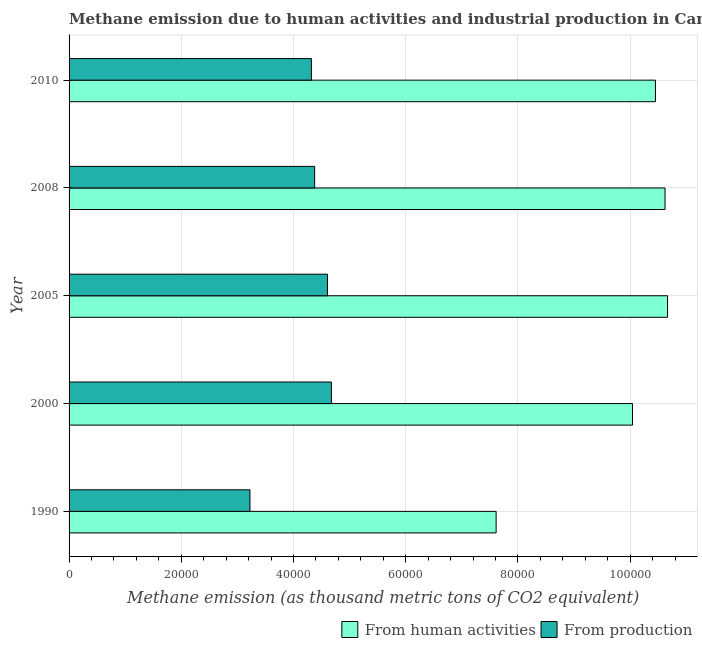How many different coloured bars are there?
Ensure brevity in your answer.  2. How many bars are there on the 4th tick from the top?
Your answer should be compact. 2. What is the label of the 3rd group of bars from the top?
Make the answer very short. 2005. What is the amount of emissions generated from industries in 1990?
Your answer should be compact. 3.22e+04. Across all years, what is the maximum amount of emissions from human activities?
Your answer should be compact. 1.07e+05. Across all years, what is the minimum amount of emissions generated from industries?
Keep it short and to the point. 3.22e+04. In which year was the amount of emissions generated from industries minimum?
Your answer should be compact. 1990. What is the total amount of emissions generated from industries in the graph?
Offer a terse response. 2.12e+05. What is the difference between the amount of emissions generated from industries in 2008 and that in 2010?
Your response must be concise. 582.1. What is the difference between the amount of emissions from human activities in 2000 and the amount of emissions generated from industries in 2005?
Give a very brief answer. 5.44e+04. What is the average amount of emissions from human activities per year?
Your answer should be very brief. 9.88e+04. In the year 2010, what is the difference between the amount of emissions from human activities and amount of emissions generated from industries?
Offer a very short reply. 6.13e+04. In how many years, is the amount of emissions generated from industries greater than 52000 thousand metric tons?
Provide a succinct answer. 0. What is the ratio of the amount of emissions generated from industries in 2005 to that in 2010?
Provide a short and direct response. 1.07. What is the difference between the highest and the second highest amount of emissions generated from industries?
Your response must be concise. 705.9. What is the difference between the highest and the lowest amount of emissions from human activities?
Your response must be concise. 3.06e+04. Is the sum of the amount of emissions generated from industries in 1990 and 2010 greater than the maximum amount of emissions from human activities across all years?
Provide a short and direct response. No. What does the 1st bar from the top in 2010 represents?
Give a very brief answer. From production. What does the 2nd bar from the bottom in 2000 represents?
Keep it short and to the point. From production. How many years are there in the graph?
Ensure brevity in your answer.  5. What is the difference between two consecutive major ticks on the X-axis?
Offer a terse response. 2.00e+04. Are the values on the major ticks of X-axis written in scientific E-notation?
Ensure brevity in your answer.  No. Does the graph contain any zero values?
Your answer should be very brief. No. How are the legend labels stacked?
Provide a short and direct response. Horizontal. What is the title of the graph?
Offer a terse response. Methane emission due to human activities and industrial production in Canada. Does "Non-resident workers" appear as one of the legend labels in the graph?
Provide a succinct answer. No. What is the label or title of the X-axis?
Your answer should be compact. Methane emission (as thousand metric tons of CO2 equivalent). What is the Methane emission (as thousand metric tons of CO2 equivalent) in From human activities in 1990?
Make the answer very short. 7.61e+04. What is the Methane emission (as thousand metric tons of CO2 equivalent) in From production in 1990?
Offer a terse response. 3.22e+04. What is the Methane emission (as thousand metric tons of CO2 equivalent) of From human activities in 2000?
Your answer should be compact. 1.00e+05. What is the Methane emission (as thousand metric tons of CO2 equivalent) in From production in 2000?
Your answer should be compact. 4.68e+04. What is the Methane emission (as thousand metric tons of CO2 equivalent) of From human activities in 2005?
Offer a terse response. 1.07e+05. What is the Methane emission (as thousand metric tons of CO2 equivalent) of From production in 2005?
Your response must be concise. 4.60e+04. What is the Methane emission (as thousand metric tons of CO2 equivalent) of From human activities in 2008?
Give a very brief answer. 1.06e+05. What is the Methane emission (as thousand metric tons of CO2 equivalent) of From production in 2008?
Your response must be concise. 4.38e+04. What is the Methane emission (as thousand metric tons of CO2 equivalent) of From human activities in 2010?
Your answer should be very brief. 1.04e+05. What is the Methane emission (as thousand metric tons of CO2 equivalent) of From production in 2010?
Offer a terse response. 4.32e+04. Across all years, what is the maximum Methane emission (as thousand metric tons of CO2 equivalent) of From human activities?
Your answer should be very brief. 1.07e+05. Across all years, what is the maximum Methane emission (as thousand metric tons of CO2 equivalent) in From production?
Provide a short and direct response. 4.68e+04. Across all years, what is the minimum Methane emission (as thousand metric tons of CO2 equivalent) of From human activities?
Provide a succinct answer. 7.61e+04. Across all years, what is the minimum Methane emission (as thousand metric tons of CO2 equivalent) in From production?
Keep it short and to the point. 3.22e+04. What is the total Methane emission (as thousand metric tons of CO2 equivalent) in From human activities in the graph?
Your response must be concise. 4.94e+05. What is the total Methane emission (as thousand metric tons of CO2 equivalent) of From production in the graph?
Ensure brevity in your answer.  2.12e+05. What is the difference between the Methane emission (as thousand metric tons of CO2 equivalent) of From human activities in 1990 and that in 2000?
Provide a short and direct response. -2.43e+04. What is the difference between the Methane emission (as thousand metric tons of CO2 equivalent) in From production in 1990 and that in 2000?
Keep it short and to the point. -1.45e+04. What is the difference between the Methane emission (as thousand metric tons of CO2 equivalent) of From human activities in 1990 and that in 2005?
Make the answer very short. -3.06e+04. What is the difference between the Methane emission (as thousand metric tons of CO2 equivalent) in From production in 1990 and that in 2005?
Your answer should be very brief. -1.38e+04. What is the difference between the Methane emission (as thousand metric tons of CO2 equivalent) in From human activities in 1990 and that in 2008?
Provide a short and direct response. -3.01e+04. What is the difference between the Methane emission (as thousand metric tons of CO2 equivalent) in From production in 1990 and that in 2008?
Offer a very short reply. -1.15e+04. What is the difference between the Methane emission (as thousand metric tons of CO2 equivalent) in From human activities in 1990 and that in 2010?
Your answer should be compact. -2.84e+04. What is the difference between the Methane emission (as thousand metric tons of CO2 equivalent) in From production in 1990 and that in 2010?
Ensure brevity in your answer.  -1.09e+04. What is the difference between the Methane emission (as thousand metric tons of CO2 equivalent) of From human activities in 2000 and that in 2005?
Provide a short and direct response. -6253.4. What is the difference between the Methane emission (as thousand metric tons of CO2 equivalent) in From production in 2000 and that in 2005?
Provide a short and direct response. 705.9. What is the difference between the Methane emission (as thousand metric tons of CO2 equivalent) in From human activities in 2000 and that in 2008?
Give a very brief answer. -5804.7. What is the difference between the Methane emission (as thousand metric tons of CO2 equivalent) of From production in 2000 and that in 2008?
Provide a short and direct response. 2987.1. What is the difference between the Methane emission (as thousand metric tons of CO2 equivalent) in From human activities in 2000 and that in 2010?
Make the answer very short. -4095.9. What is the difference between the Methane emission (as thousand metric tons of CO2 equivalent) in From production in 2000 and that in 2010?
Your answer should be compact. 3569.2. What is the difference between the Methane emission (as thousand metric tons of CO2 equivalent) of From human activities in 2005 and that in 2008?
Provide a short and direct response. 448.7. What is the difference between the Methane emission (as thousand metric tons of CO2 equivalent) of From production in 2005 and that in 2008?
Keep it short and to the point. 2281.2. What is the difference between the Methane emission (as thousand metric tons of CO2 equivalent) in From human activities in 2005 and that in 2010?
Your response must be concise. 2157.5. What is the difference between the Methane emission (as thousand metric tons of CO2 equivalent) of From production in 2005 and that in 2010?
Your response must be concise. 2863.3. What is the difference between the Methane emission (as thousand metric tons of CO2 equivalent) in From human activities in 2008 and that in 2010?
Offer a very short reply. 1708.8. What is the difference between the Methane emission (as thousand metric tons of CO2 equivalent) in From production in 2008 and that in 2010?
Your response must be concise. 582.1. What is the difference between the Methane emission (as thousand metric tons of CO2 equivalent) in From human activities in 1990 and the Methane emission (as thousand metric tons of CO2 equivalent) in From production in 2000?
Offer a very short reply. 2.94e+04. What is the difference between the Methane emission (as thousand metric tons of CO2 equivalent) of From human activities in 1990 and the Methane emission (as thousand metric tons of CO2 equivalent) of From production in 2005?
Offer a terse response. 3.01e+04. What is the difference between the Methane emission (as thousand metric tons of CO2 equivalent) in From human activities in 1990 and the Methane emission (as thousand metric tons of CO2 equivalent) in From production in 2008?
Offer a very short reply. 3.23e+04. What is the difference between the Methane emission (as thousand metric tons of CO2 equivalent) in From human activities in 1990 and the Methane emission (as thousand metric tons of CO2 equivalent) in From production in 2010?
Provide a succinct answer. 3.29e+04. What is the difference between the Methane emission (as thousand metric tons of CO2 equivalent) in From human activities in 2000 and the Methane emission (as thousand metric tons of CO2 equivalent) in From production in 2005?
Give a very brief answer. 5.44e+04. What is the difference between the Methane emission (as thousand metric tons of CO2 equivalent) in From human activities in 2000 and the Methane emission (as thousand metric tons of CO2 equivalent) in From production in 2008?
Provide a succinct answer. 5.66e+04. What is the difference between the Methane emission (as thousand metric tons of CO2 equivalent) in From human activities in 2000 and the Methane emission (as thousand metric tons of CO2 equivalent) in From production in 2010?
Make the answer very short. 5.72e+04. What is the difference between the Methane emission (as thousand metric tons of CO2 equivalent) of From human activities in 2005 and the Methane emission (as thousand metric tons of CO2 equivalent) of From production in 2008?
Your answer should be very brief. 6.29e+04. What is the difference between the Methane emission (as thousand metric tons of CO2 equivalent) in From human activities in 2005 and the Methane emission (as thousand metric tons of CO2 equivalent) in From production in 2010?
Offer a terse response. 6.35e+04. What is the difference between the Methane emission (as thousand metric tons of CO2 equivalent) in From human activities in 2008 and the Methane emission (as thousand metric tons of CO2 equivalent) in From production in 2010?
Make the answer very short. 6.30e+04. What is the average Methane emission (as thousand metric tons of CO2 equivalent) in From human activities per year?
Ensure brevity in your answer.  9.88e+04. What is the average Methane emission (as thousand metric tons of CO2 equivalent) in From production per year?
Ensure brevity in your answer.  4.24e+04. In the year 1990, what is the difference between the Methane emission (as thousand metric tons of CO2 equivalent) of From human activities and Methane emission (as thousand metric tons of CO2 equivalent) of From production?
Your response must be concise. 4.39e+04. In the year 2000, what is the difference between the Methane emission (as thousand metric tons of CO2 equivalent) of From human activities and Methane emission (as thousand metric tons of CO2 equivalent) of From production?
Offer a terse response. 5.37e+04. In the year 2005, what is the difference between the Methane emission (as thousand metric tons of CO2 equivalent) in From human activities and Methane emission (as thousand metric tons of CO2 equivalent) in From production?
Keep it short and to the point. 6.06e+04. In the year 2008, what is the difference between the Methane emission (as thousand metric tons of CO2 equivalent) in From human activities and Methane emission (as thousand metric tons of CO2 equivalent) in From production?
Provide a short and direct response. 6.24e+04. In the year 2010, what is the difference between the Methane emission (as thousand metric tons of CO2 equivalent) of From human activities and Methane emission (as thousand metric tons of CO2 equivalent) of From production?
Give a very brief answer. 6.13e+04. What is the ratio of the Methane emission (as thousand metric tons of CO2 equivalent) of From human activities in 1990 to that in 2000?
Provide a succinct answer. 0.76. What is the ratio of the Methane emission (as thousand metric tons of CO2 equivalent) in From production in 1990 to that in 2000?
Your answer should be very brief. 0.69. What is the ratio of the Methane emission (as thousand metric tons of CO2 equivalent) in From human activities in 1990 to that in 2005?
Provide a short and direct response. 0.71. What is the ratio of the Methane emission (as thousand metric tons of CO2 equivalent) in From production in 1990 to that in 2005?
Give a very brief answer. 0.7. What is the ratio of the Methane emission (as thousand metric tons of CO2 equivalent) in From human activities in 1990 to that in 2008?
Provide a short and direct response. 0.72. What is the ratio of the Methane emission (as thousand metric tons of CO2 equivalent) in From production in 1990 to that in 2008?
Give a very brief answer. 0.74. What is the ratio of the Methane emission (as thousand metric tons of CO2 equivalent) in From human activities in 1990 to that in 2010?
Ensure brevity in your answer.  0.73. What is the ratio of the Methane emission (as thousand metric tons of CO2 equivalent) of From production in 1990 to that in 2010?
Make the answer very short. 0.75. What is the ratio of the Methane emission (as thousand metric tons of CO2 equivalent) of From human activities in 2000 to that in 2005?
Offer a very short reply. 0.94. What is the ratio of the Methane emission (as thousand metric tons of CO2 equivalent) in From production in 2000 to that in 2005?
Offer a very short reply. 1.02. What is the ratio of the Methane emission (as thousand metric tons of CO2 equivalent) in From human activities in 2000 to that in 2008?
Your answer should be compact. 0.95. What is the ratio of the Methane emission (as thousand metric tons of CO2 equivalent) of From production in 2000 to that in 2008?
Provide a succinct answer. 1.07. What is the ratio of the Methane emission (as thousand metric tons of CO2 equivalent) of From human activities in 2000 to that in 2010?
Offer a very short reply. 0.96. What is the ratio of the Methane emission (as thousand metric tons of CO2 equivalent) in From production in 2000 to that in 2010?
Give a very brief answer. 1.08. What is the ratio of the Methane emission (as thousand metric tons of CO2 equivalent) in From human activities in 2005 to that in 2008?
Offer a terse response. 1. What is the ratio of the Methane emission (as thousand metric tons of CO2 equivalent) in From production in 2005 to that in 2008?
Provide a short and direct response. 1.05. What is the ratio of the Methane emission (as thousand metric tons of CO2 equivalent) of From human activities in 2005 to that in 2010?
Your response must be concise. 1.02. What is the ratio of the Methane emission (as thousand metric tons of CO2 equivalent) of From production in 2005 to that in 2010?
Provide a succinct answer. 1.07. What is the ratio of the Methane emission (as thousand metric tons of CO2 equivalent) in From human activities in 2008 to that in 2010?
Your answer should be compact. 1.02. What is the ratio of the Methane emission (as thousand metric tons of CO2 equivalent) in From production in 2008 to that in 2010?
Provide a succinct answer. 1.01. What is the difference between the highest and the second highest Methane emission (as thousand metric tons of CO2 equivalent) of From human activities?
Your answer should be very brief. 448.7. What is the difference between the highest and the second highest Methane emission (as thousand metric tons of CO2 equivalent) of From production?
Provide a short and direct response. 705.9. What is the difference between the highest and the lowest Methane emission (as thousand metric tons of CO2 equivalent) of From human activities?
Keep it short and to the point. 3.06e+04. What is the difference between the highest and the lowest Methane emission (as thousand metric tons of CO2 equivalent) in From production?
Your response must be concise. 1.45e+04. 